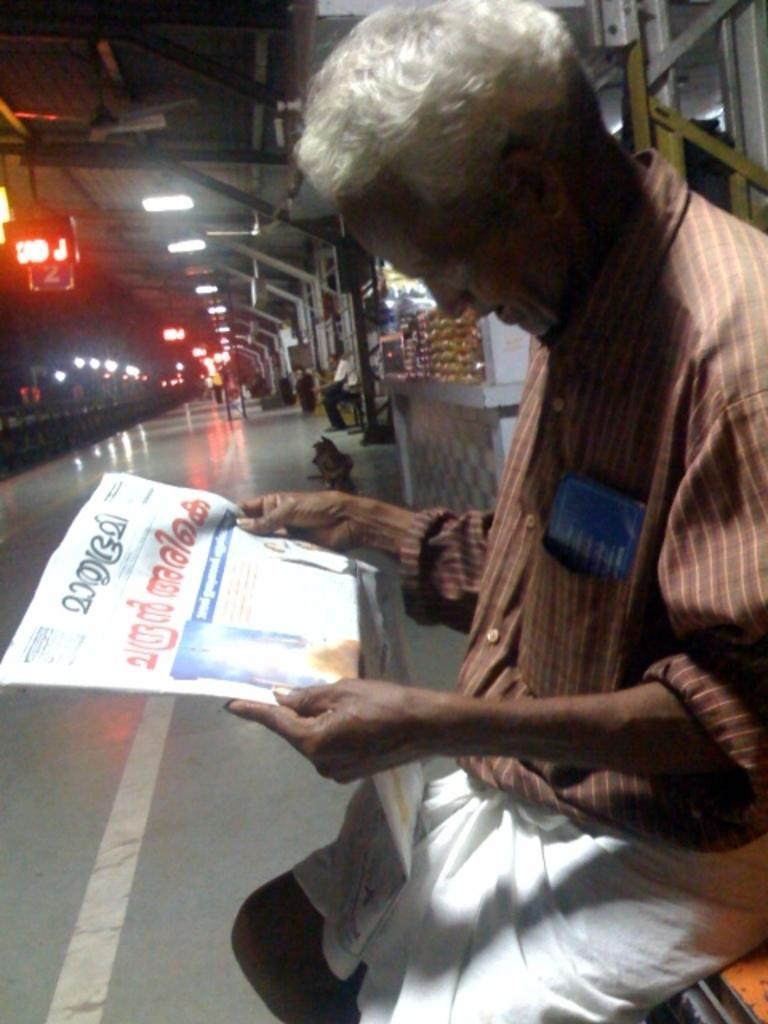Please provide a concise description of this image. In this image I can see the platform, few persons sitting on the platform, a person holding a newspaper, few lights, few poles, few stores and a red colored led board. 